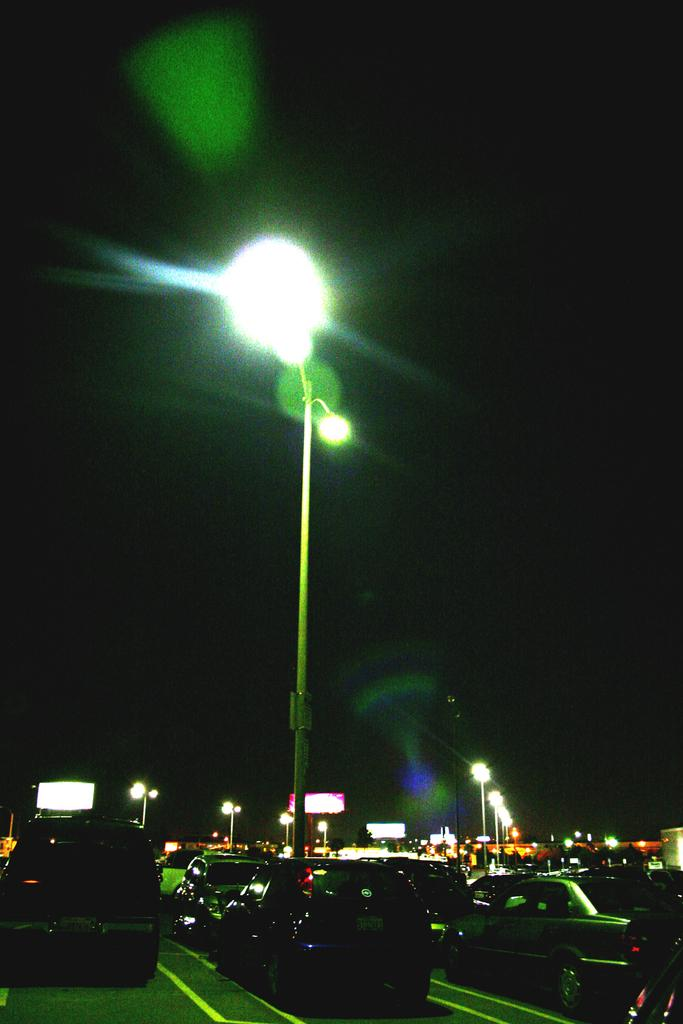What structures are present in the image that provide illumination? There are light poles in the image. What objects can be seen in the image that are used for displaying information or advertisements? There are boards in the image. What type of transportation is visible on the road in the image? There are vehicles on the road in the image. How would you describe the overall lighting condition in the image? The image is dark. What type of process is being carried out by the ball in the image? There is no ball present in the image, so no process involving a ball can be observed. How many screws can be seen holding the light poles in the image? There is no information about screws in the image, as it only mentions the presence of light poles. 